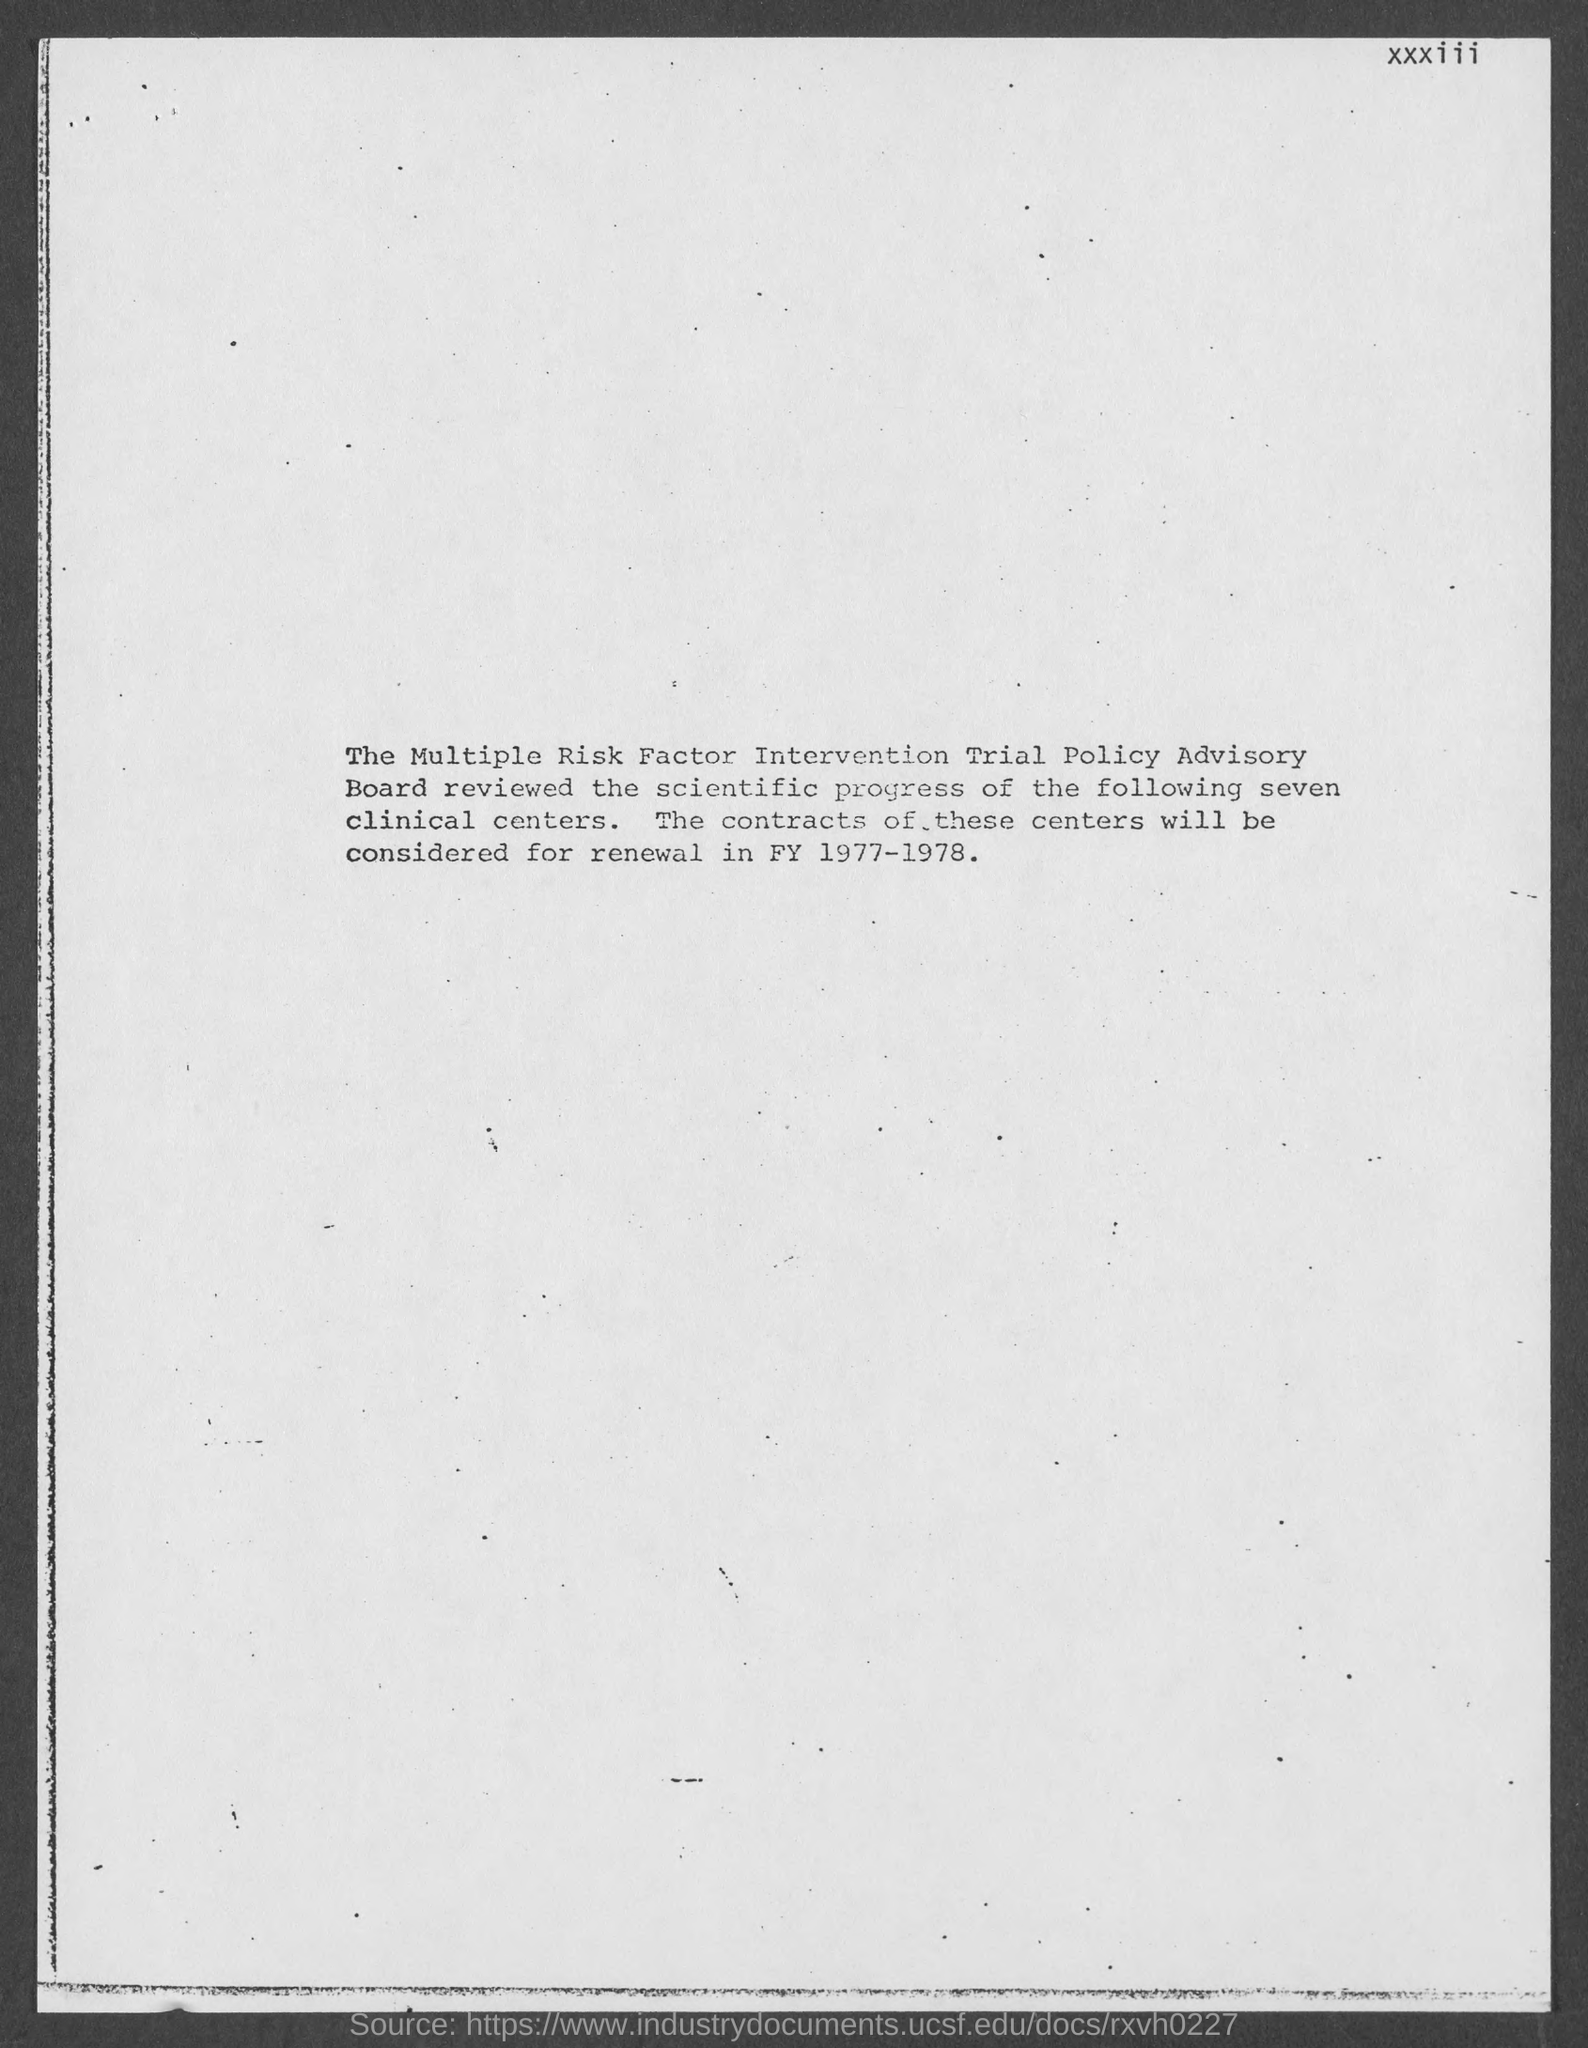Mention a couple of crucial points in this snapshot. The contracts of these centers will be considered for renewal in the fiscal year 1977-1978. 